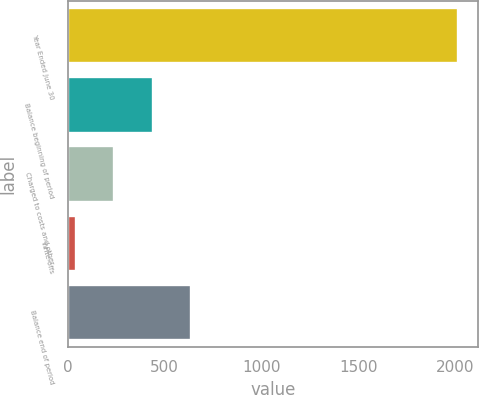Convert chart. <chart><loc_0><loc_0><loc_500><loc_500><bar_chart><fcel>Year Ended June 30<fcel>Balance beginning of period<fcel>Charged to costs and other<fcel>Write-offs<fcel>Balance end of period<nl><fcel>2015<fcel>437.4<fcel>240.2<fcel>43<fcel>634.6<nl></chart> 